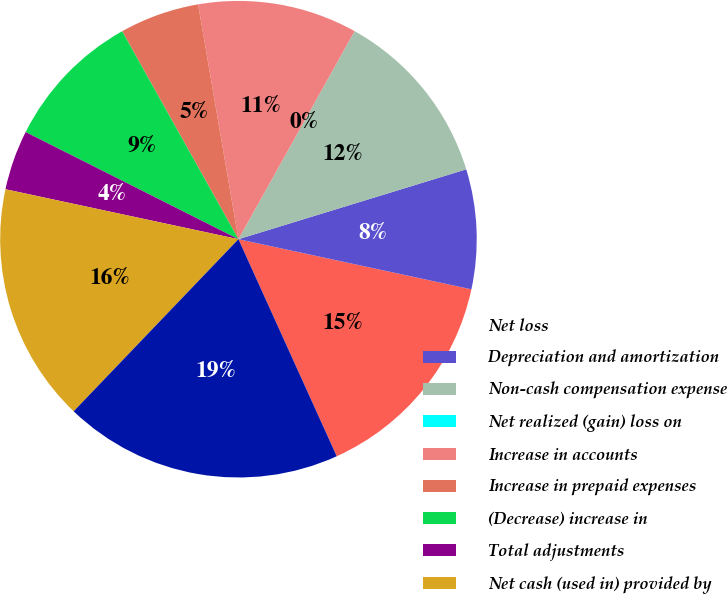Convert chart. <chart><loc_0><loc_0><loc_500><loc_500><pie_chart><fcel>Net loss<fcel>Depreciation and amortization<fcel>Non-cash compensation expense<fcel>Net realized (gain) loss on<fcel>Increase in accounts<fcel>Increase in prepaid expenses<fcel>(Decrease) increase in<fcel>Total adjustments<fcel>Net cash (used in) provided by<fcel>Purchases of marketable<nl><fcel>14.86%<fcel>8.11%<fcel>12.16%<fcel>0.0%<fcel>10.81%<fcel>5.41%<fcel>9.46%<fcel>4.06%<fcel>16.21%<fcel>18.92%<nl></chart> 